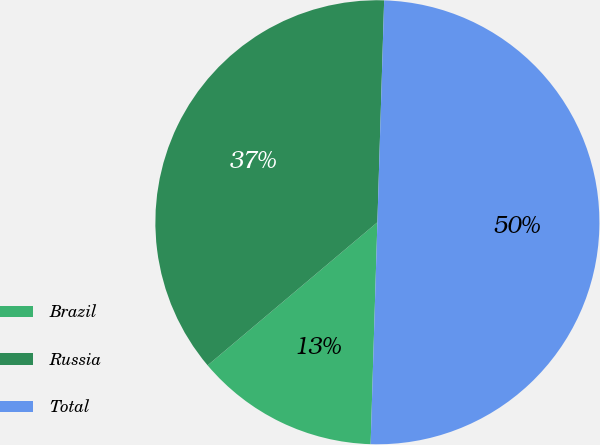<chart> <loc_0><loc_0><loc_500><loc_500><pie_chart><fcel>Brazil<fcel>Russia<fcel>Total<nl><fcel>13.37%<fcel>36.63%<fcel>50.0%<nl></chart> 